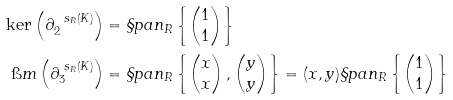<formula> <loc_0><loc_0><loc_500><loc_500>\ker \left ( \partial ^ { \ s _ { R } ( K ) } _ { 2 } \right ) & = \S p a n _ { R } \left \{ \begin{pmatrix} 1 \\ 1 \end{pmatrix} \right \} \\ \i m \left ( \partial ^ { \ s _ { R } ( K ) } _ { 3 } \right ) & = \S p a n _ { R } \left \{ \begin{pmatrix} x \\ x \end{pmatrix} , \begin{pmatrix} y \\ y \end{pmatrix} \right \} = ( x , y ) \S p a n _ { R } \left \{ \begin{pmatrix} 1 \\ 1 \end{pmatrix} \right \}</formula> 